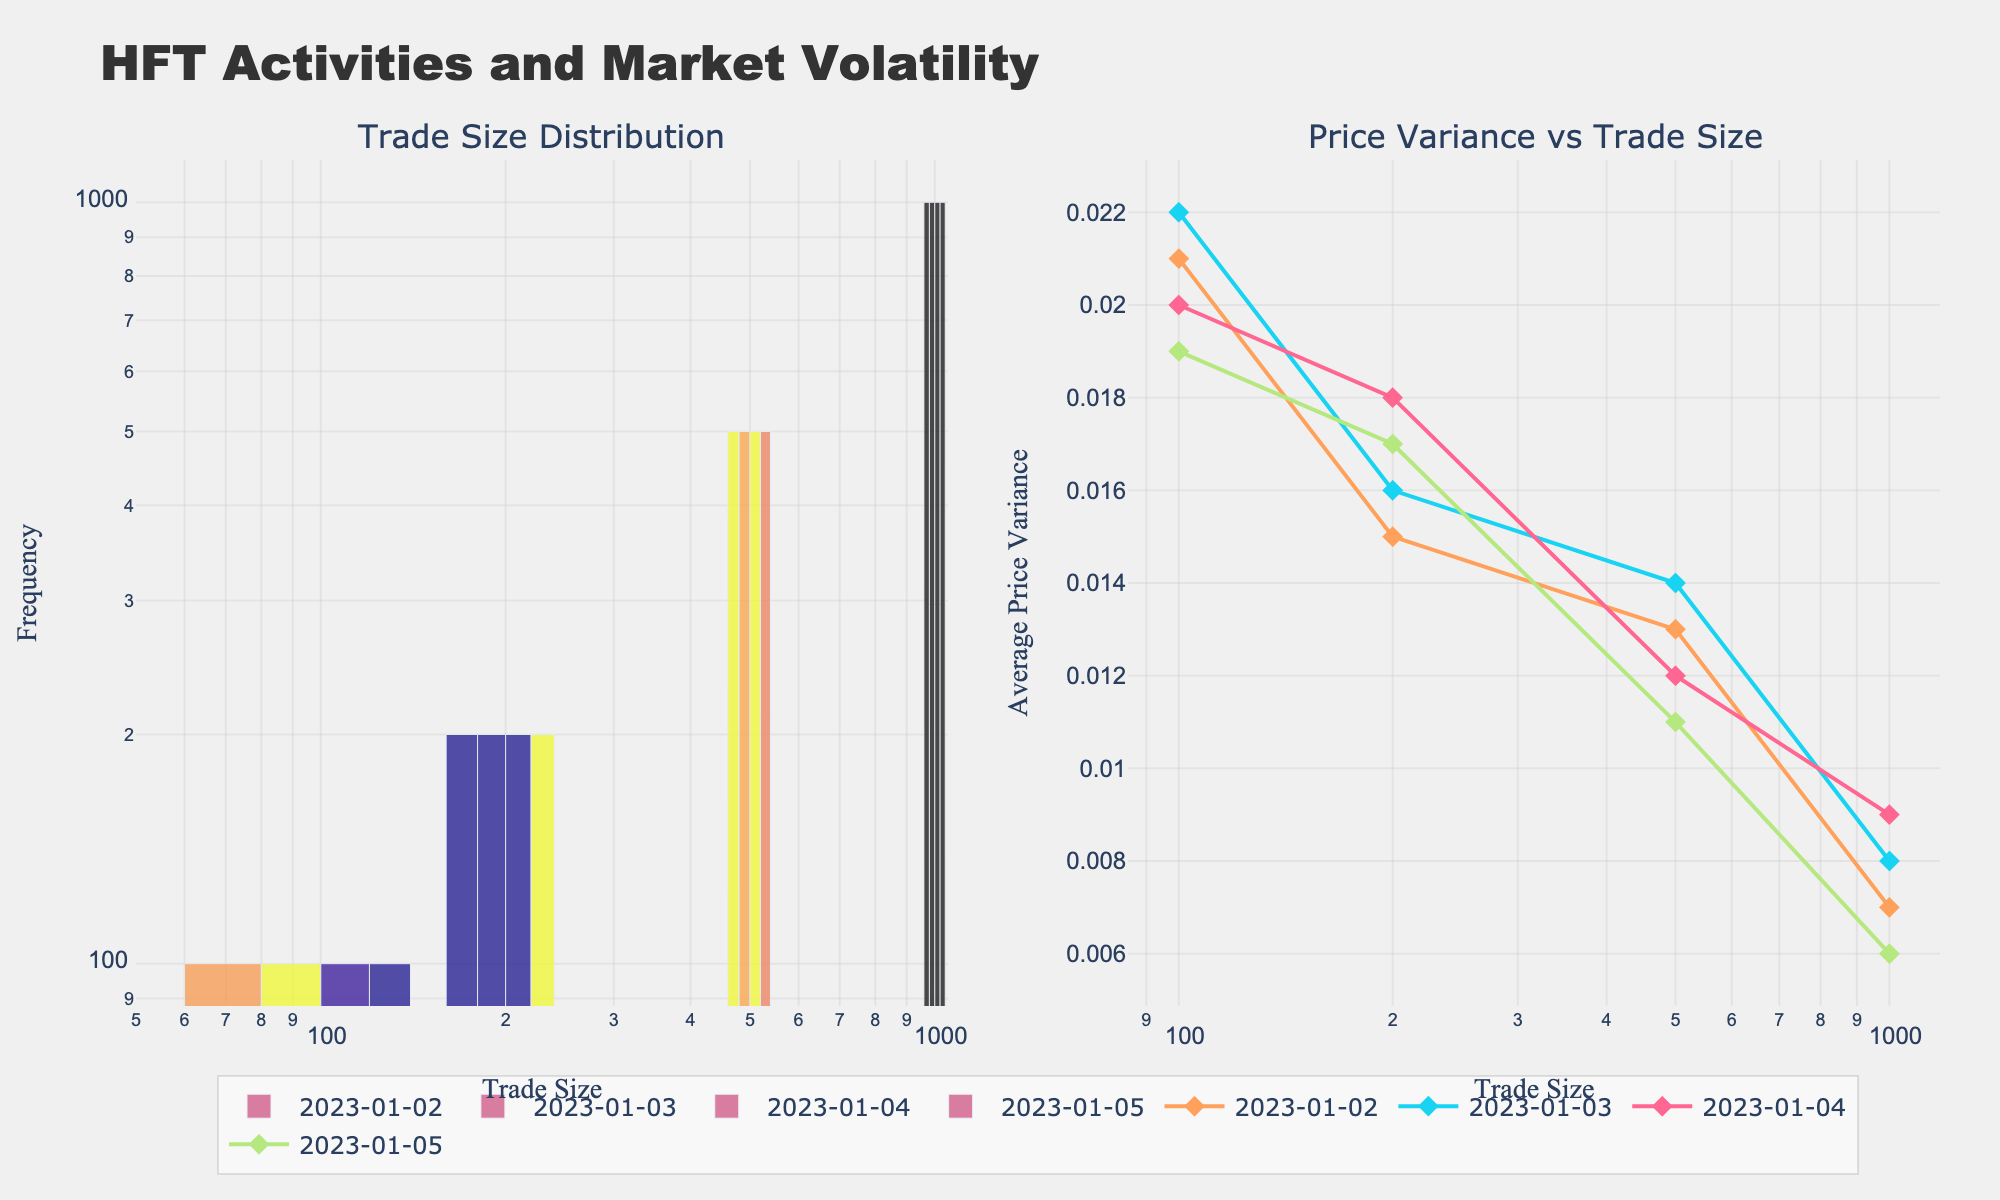What's the title of the figure? The title of the figure appears prominently at the top, clearly stating the overall theme of the plots.
Answer: HFT Activities and Market Volatility What type of scales are used on the x-axis and y-axis of the first subplot? Inspecting the axes titles and noting the use of 'log' text next to the axes reveals they are logarithmic scales.
Answer: Logarithmic Which date shows the highest trade frequency for the smallest trade size in the first subplot? Look at the trade size of 100 on the x-axis in the first subplot and compare the heights of the bars for different dates. The tallest bar indicates the highest frequency.
Answer: 2023-01-03 What is the trend in price variance as trade size increases for the date 2023-01-05 in the second subplot? Observe the line for 2023-01-05 in the second subplot, noting how the y-values (average price variance) change as the x-values (trade size) increase.
Answer: Decreasing How does the average price variance for trade sizes of 500 compare across all the dates? Check the y-values corresponding to the x-value of 500 in the second subplot for all dates. Compare the heights or values directly.
Answer: Nearly similar (around 0.012-0.014) For which trade size does the price variance show the most variability among the dates? For each trade size in the second subplot, observe the spread of y-values across different dates and identify the trade size with the widest range.
Answer: 200 Is there an overall relationship between trade size and price variance? Analyze the general pattern of the lines in the second subplot across different dates to deduce the relationship between increasing trade size and price variance.
Answer: Negative correlation Which date has the lowest average price variance for the trade size of 1000? Look at the y-values corresponding to the x-value of 1000 in the second subplot and identify the smallest value.
Answer: 2023-01-05 Between which trade sizes does the largest drop in average price variance occur for the date 2023-01-04? Observe the line for 2023-01-04 in the second subplot and identify the trade sizes between which the steepest decline in y-values occurs.
Answer: Between 200 and 500 What can be inferred about the frequency of higher trade sizes compared to lower trade sizes in the first subplot across all dates? Compare the height of bars for higher trade sizes (e.g., 1000) against lower trade sizes (e.g., 100) for all dates in the first subplot.
Answer: Lower frequency for higher trade sizes 